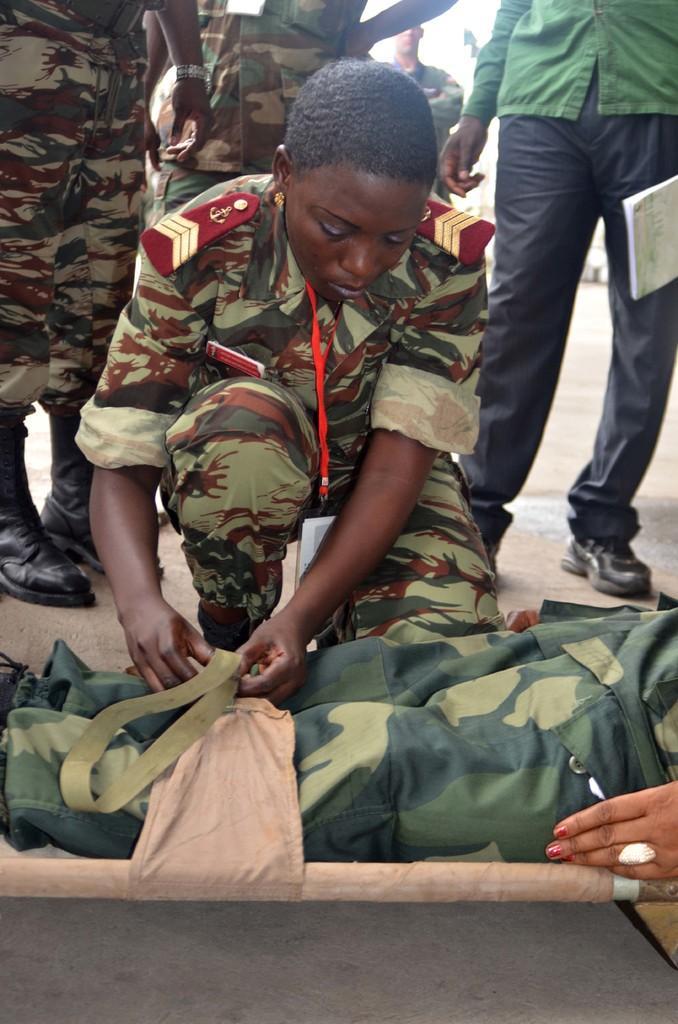Describe this image in one or two sentences. In this picture there is a girl who is lying on the floor in the center of the image and there is another girl in the center of the image and there are other people those who are standing at the top side of the image. 